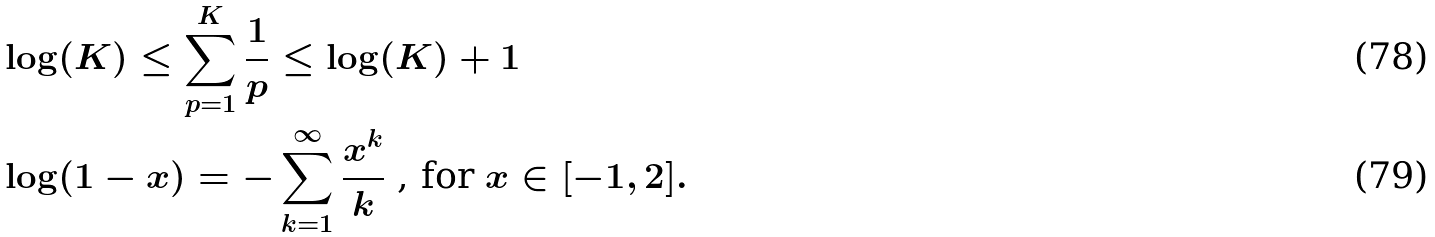<formula> <loc_0><loc_0><loc_500><loc_500>& \log ( K ) \leq \sum _ { p = 1 } ^ { K } \frac { 1 } { p } \leq \log ( K ) + 1 \\ & \log ( 1 - x ) = - \sum _ { k = 1 } ^ { \infty } \frac { x ^ { k } } { k } \text { , for $x\in[-1,2]$} .</formula> 